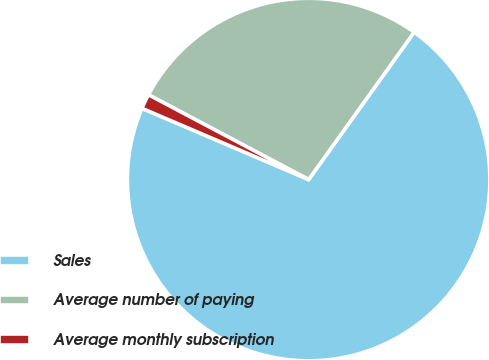<chart> <loc_0><loc_0><loc_500><loc_500><pie_chart><fcel>Sales<fcel>Average number of paying<fcel>Average monthly subscription<nl><fcel>71.54%<fcel>27.14%<fcel>1.32%<nl></chart> 